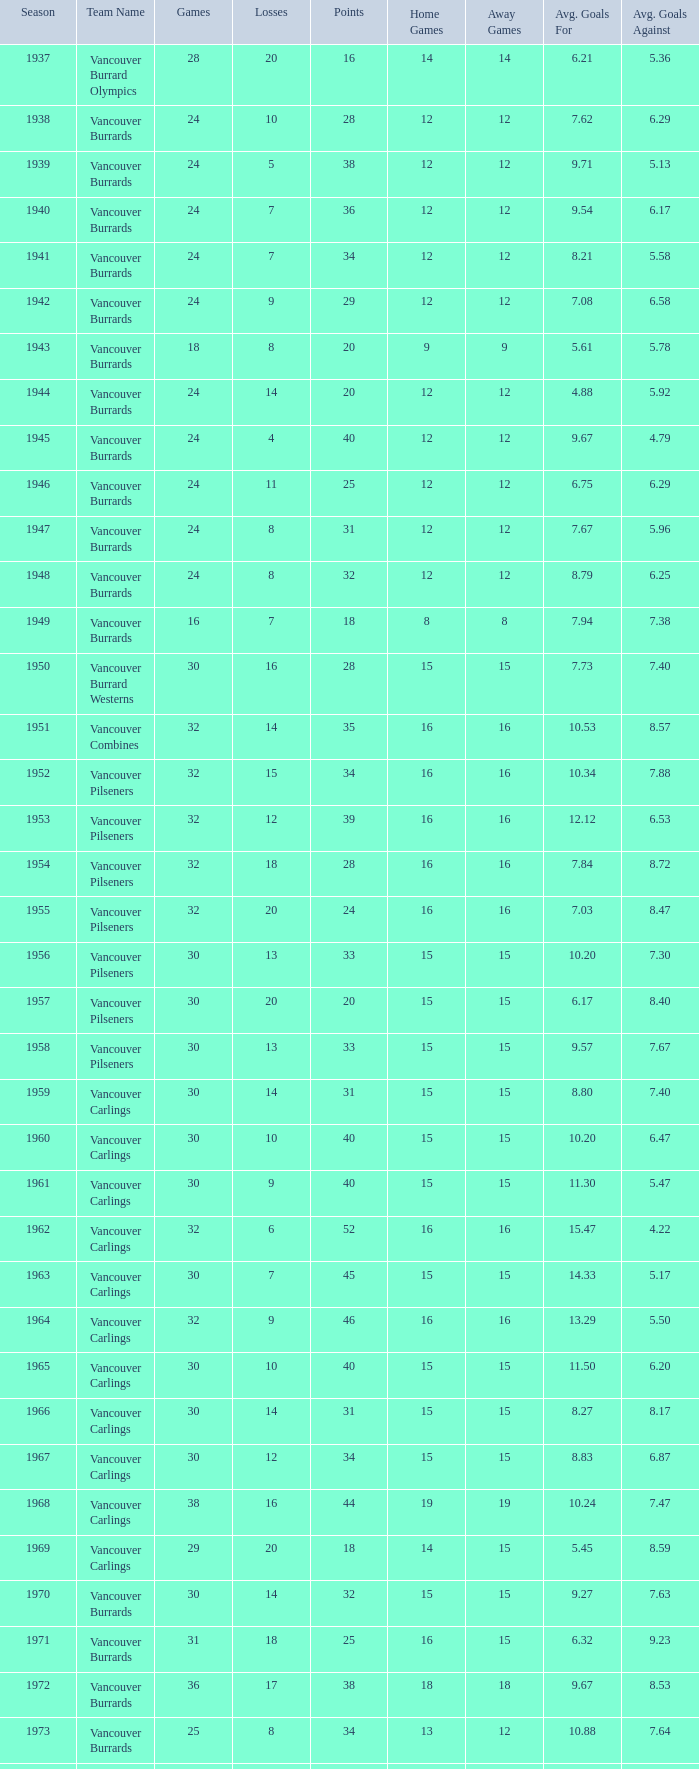What's the total losses for the vancouver burrards in the 1947 season with fewer than 24 games? 0.0. 